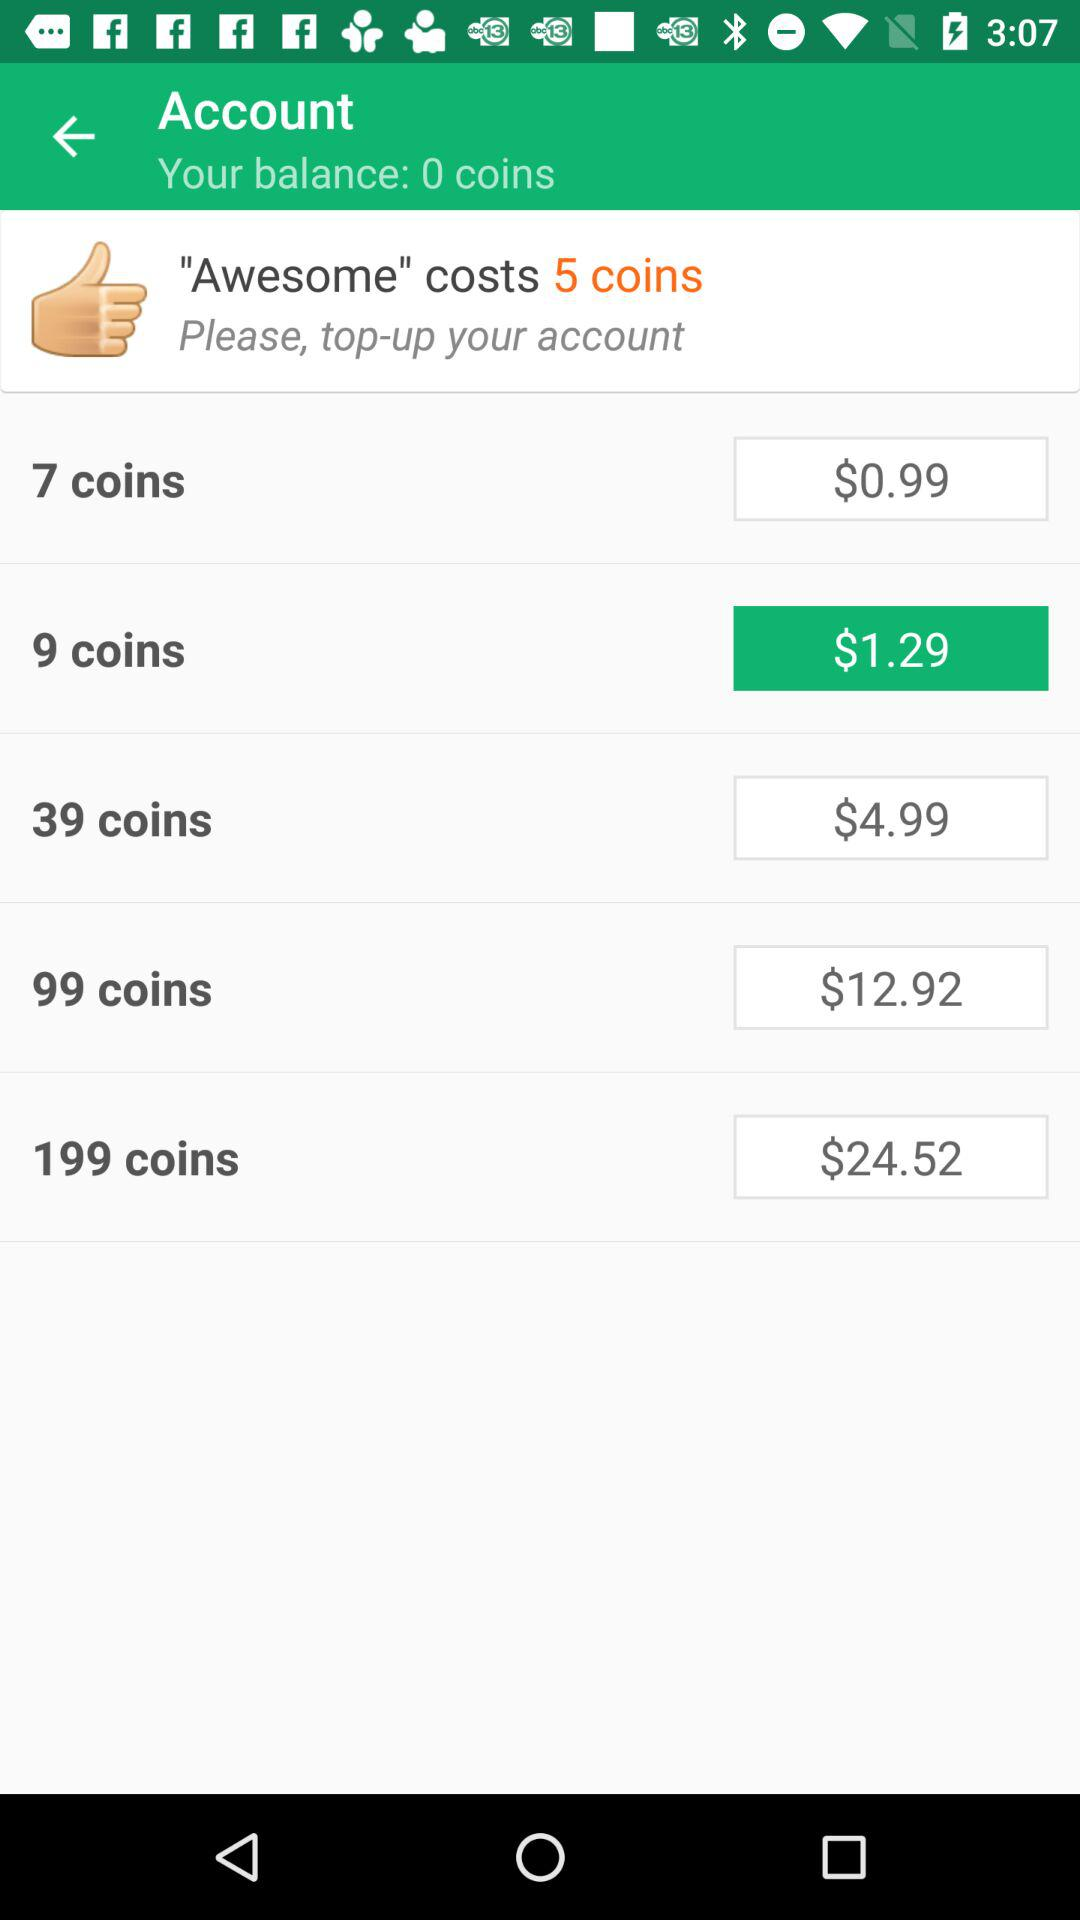How many coins can I get for $1.29?
Answer the question using a single word or phrase. 9 